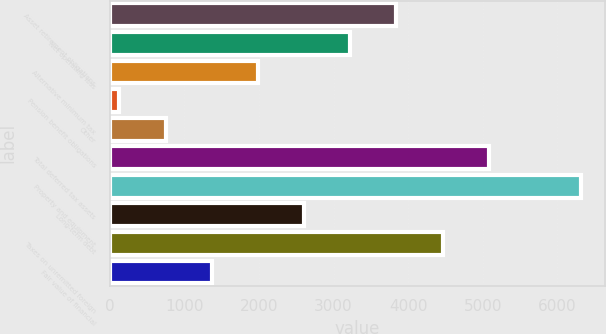Convert chart. <chart><loc_0><loc_0><loc_500><loc_500><bar_chart><fcel>Asset retirement obligations<fcel>Net operating loss<fcel>Alternative minimum tax<fcel>Pension benefit obligations<fcel>Other<fcel>Total deferred tax assets<fcel>Property and equipment<fcel>Long-term debt<fcel>Taxes on unremitted foreign<fcel>Fair value of financial<nl><fcel>3844.2<fcel>3225<fcel>1986.6<fcel>129<fcel>748.2<fcel>5082.6<fcel>6321<fcel>2605.8<fcel>4463.4<fcel>1367.4<nl></chart> 